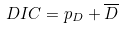Convert formula to latex. <formula><loc_0><loc_0><loc_500><loc_500>D I C = p _ { D } + \overline { D }</formula> 